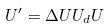<formula> <loc_0><loc_0><loc_500><loc_500>U ^ { \prime } = \Delta U U _ { d } U</formula> 